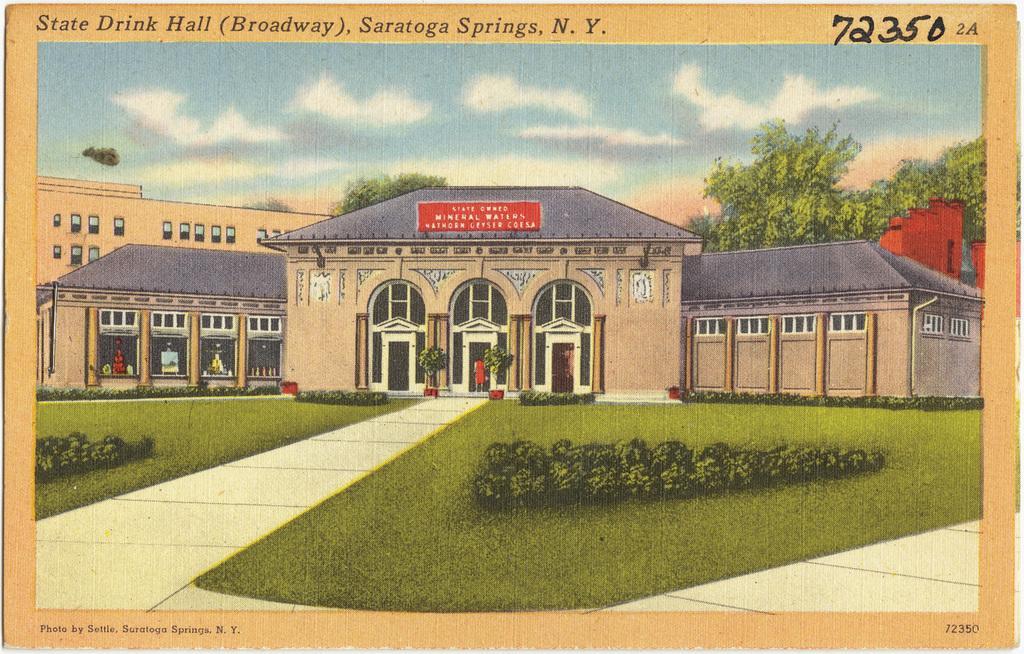Could you give a brief overview of what you see in this image? In the picture we can see a painting of the building with three doors to it and near the door, we can see a person standing and away and besides the way we can see grass surface and some plants on it and behind the building we can see some trees and sky with clouds. 